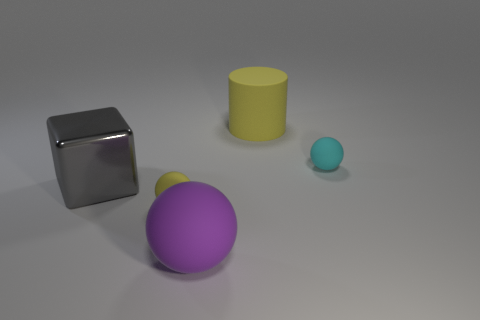How many things are either small rubber objects in front of the gray thing or small purple spheres?
Keep it short and to the point. 1. Is the color of the large rubber ball the same as the tiny rubber object that is to the left of the cylinder?
Offer a terse response. No. Is there a purple sphere that has the same size as the gray cube?
Your answer should be very brief. Yes. What is the material of the tiny sphere behind the tiny object to the left of the big yellow matte object?
Offer a terse response. Rubber. What number of blocks are the same color as the big metal object?
Offer a terse response. 0. There is a tiny cyan object that is the same material as the big yellow cylinder; what is its shape?
Your answer should be very brief. Sphere. What size is the matte ball behind the big gray thing?
Provide a succinct answer. Small. Is the number of big gray metallic things in front of the shiny cube the same as the number of tiny yellow objects that are in front of the large purple rubber object?
Offer a terse response. Yes. The sphere to the right of the large thing that is in front of the yellow thing that is on the left side of the purple rubber sphere is what color?
Give a very brief answer. Cyan. What number of things are in front of the large cylinder and on the left side of the cyan sphere?
Make the answer very short. 3. 